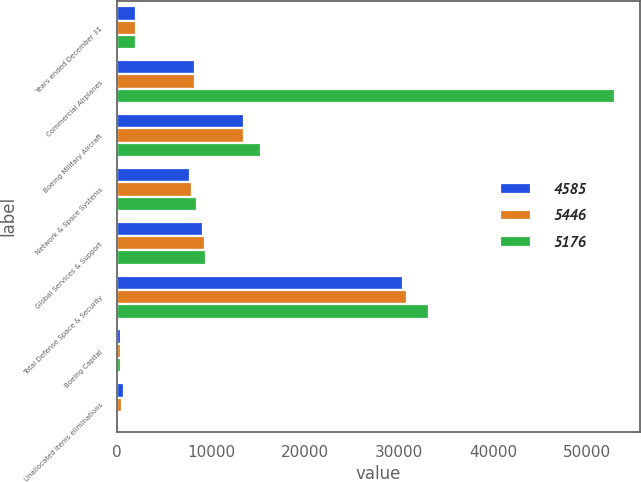Convert chart to OTSL. <chart><loc_0><loc_0><loc_500><loc_500><stacked_bar_chart><ecel><fcel>Years ended December 31<fcel>Commercial Airplanes<fcel>Boeing Military Aircraft<fcel>Network & Space Systems<fcel>Global Services & Support<fcel>Total Defense Space & Security<fcel>Boeing Capital<fcel>Unallocated items eliminations<nl><fcel>4585<fcel>2015<fcel>8257.5<fcel>13482<fcel>7751<fcel>9155<fcel>30388<fcel>413<fcel>735<nl><fcel>5446<fcel>2014<fcel>8257.5<fcel>13500<fcel>8003<fcel>9378<fcel>30881<fcel>416<fcel>525<nl><fcel>5176<fcel>2013<fcel>52981<fcel>15275<fcel>8512<fcel>9410<fcel>33197<fcel>408<fcel>37<nl></chart> 